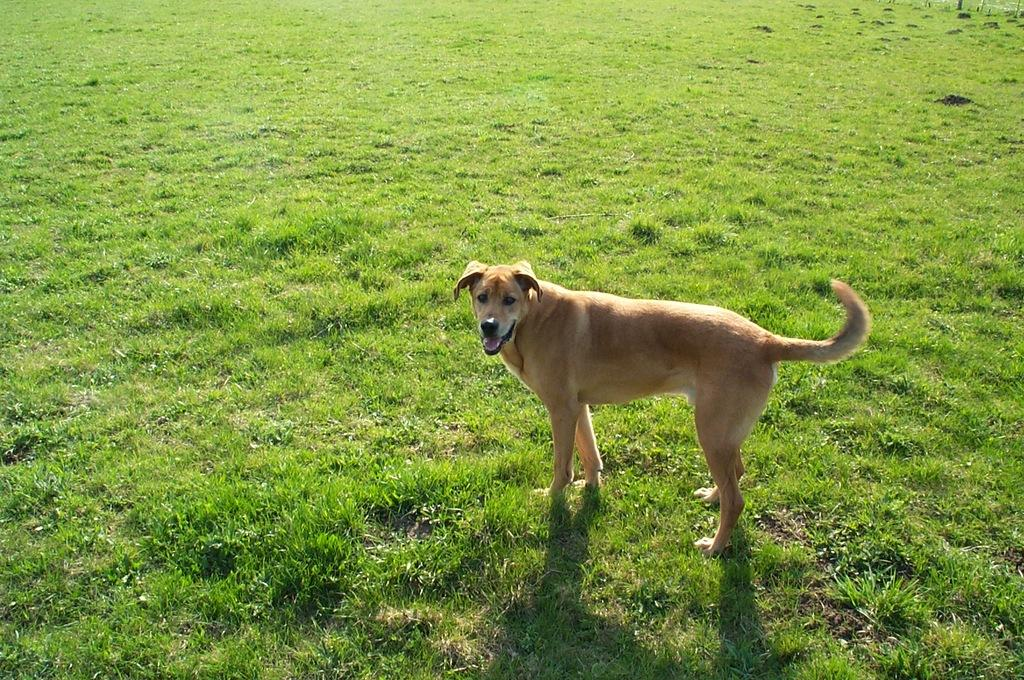What type of animal is in the image? There is a dog in the image. What is the dog doing in the image? The dog is standing on the ground. What is the surface the dog is standing on? There is grass on the ground. What is the range of the dog's vision in the image? The range of the dog's vision cannot be determined from the image alone, as it depends on factors such as the dog's eye health and the lighting conditions. 